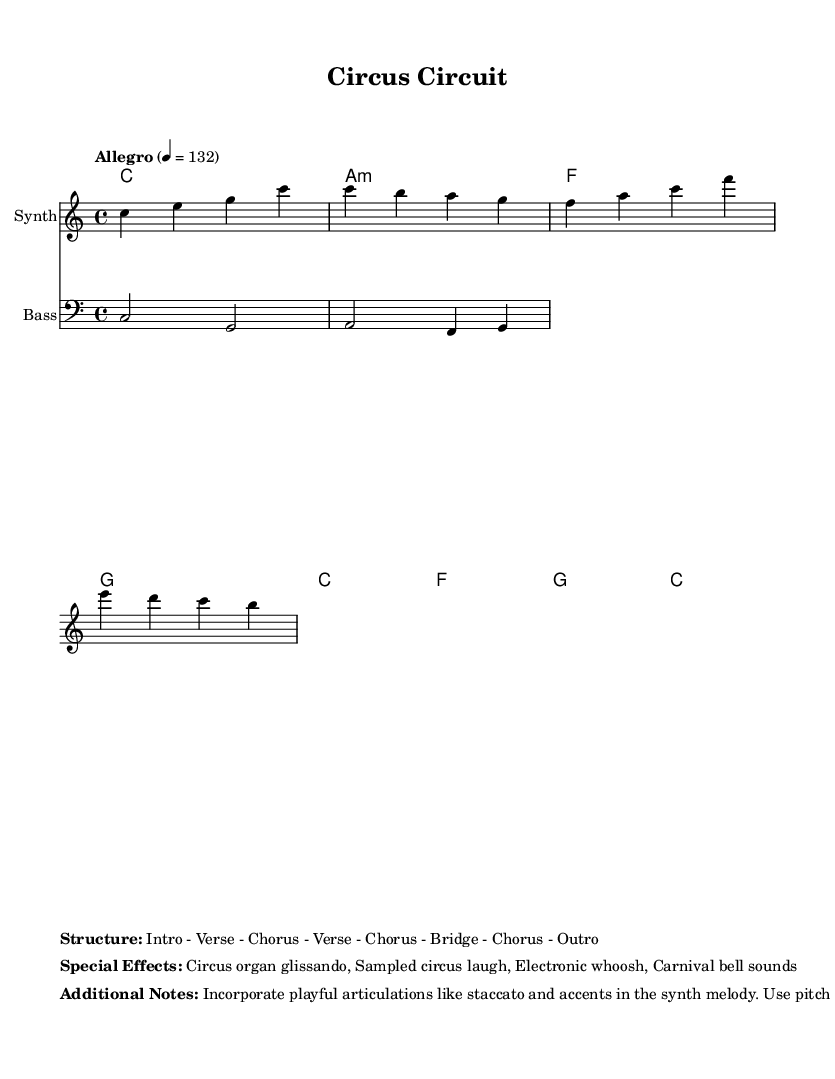What is the key signature of this music? The key signature is C major, as indicated by the absence of sharps or flats next to the clef symbol.
Answer: C major What is the time signature of this music? The time signature is 4/4, which is displayed at the beginning of the score following the key signature.
Answer: 4/4 What is the tempo marking for the piece? The tempo marking indicates "Allegro," followed by a metronome indication of 132 beats per minute, which is noted at the top of the score.
Answer: Allegro 4 = 132 How many sections are there in the structure of this music? The structured breakdown indicates there are a total of 8 sections, listed as Intro, Verse, Chorus, Verse, Chorus, Bridge, Chorus, Outro.
Answer: 8 What type of instruments are included in the score? The score features a "Synth" for the main melody and a "Bass" for the accompanying bass line, as specified at the commencement of each staff.
Answer: Synth and Bass What special effects are incorporated in the piece? The special effects mentioned include a circus organ glissando, sampled circus laugh, electronic whoosh, and carnival bell sounds, which enhance the fusion genre.
Answer: Circus organ glissando, Sampled circus laugh, Electronic whoosh, Carnival bell sounds Which articulation styles are recommended for the synth melody? The additional notes suggest incorporating playful articulations like staccato and accents, which are critical for creating a lively and engaging performance.
Answer: Staccato and accents 